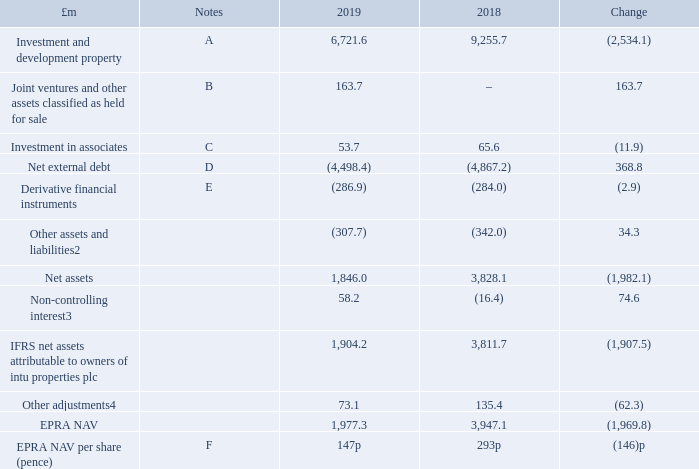IFRS balance sheet items
Our total investment in joint ventures was £524.1 million at 31 December 2019 (which includes investments in joint ventures of £326.6 million and loans to joint ventures £197.5 million), a decrease of £299.8 million from 31 December 2018. The key driver in the year related to the share of loss of joint ventures of £158.9 million, which primarily included underlying earnings of £27.9 million and a property revaluation deficit of £182.9 million, a £200.7 million transfer of intu Puerto Venecia and intu Asturias to held for sale, partially offset by the residual interest in intu Derby of £93.9 million being classified as a joint venture.
We are exposed to foreign exchange movements on our overseas investments. At 31 December 2019 the exposure was 24 per cent of net assets attributable to shareholders, the increase from the 31 December 2018 exposure of 15 per cent being due to the property revaluation deficit in the UK. Adjusted for the disposals in intu Puerto Venecia and intu Asturias, this exposure would be reduced to 15 per cent.
1 A reconciliation from the IFRS consolidated balance sheet to the amounts presented above is provided in the presentation of information on page 159. A further reconciliation of EPRA NAV to IFRS net assets attributable to owners of intu properties plc is provided within EPRA measures on page 169.
2 Other assets and liabilities includes property, plant and equipment, other non-current assets, trade and other receivables, trade and other payables, current tax liabilities, deferred tax liabilities and other payables.
3 Relates primarily to our partner’s 40 per cent stake in intu Metrocentre. The amount is considered to be recoverable in view of the £195.4 million owed to the non-controlling interest (which is included in the Group’s borrowings in note 23).
4 Other adjustments relate to fair value of derivative financial instruments, fair value of convertible bonds, deferred tax on investment and development property, share of joint ventures’ adjusted items and non-controlling interest recoverable balance not recognised in EPRA NAV.
The key drivers in the decrease in IFRS net assets attributable to owners of intu properties plc of £1,907.5 million as well as the decrease in EPRA NAV of £1,969.8 million and EPRA NAV per share of 146 pence in the year are discussed below.
A Investment and development property
Investment and development property has decreased by £2,534.1 million:
—deficit on revaluation of £1,979.7 million (see E above within the income statement section)
—disposals in the year, including the part disposal of intu Derby in July 2019, transfer of intu Puerto Venecia and intu Asturias to assets held for sale (see B below) and sundry asset disposals
—capital expenditure of £129.2 million on projects enhancing the value and appeal of our centres, including £44.5 million on the Primark anchored intu Trafford Centre’s Barton Square extension, £14.5 million on the redevelopment of intu Broadmarsh and £11.2 million on the now completed leisure extension at intu Lakeside
B Joint ventures and other assets classified as held for sale
intu Puerto Venecia and intu Asturias were classified as joint ventures held for sale at 31 December 2019 and recognised at their expected net proceeds.
intu Puerto Venecia
In December 2019 the Group announced the disposal of its joint venture interest in intu Puerto Venecia to Generali Shopping Centre Fund S.C.S. SICAV-SIF and Union Investment Real Estate GMBH for €475.3 million (intu share €237.7 million), an 11 per cent discount to the June 2019 valuation. This is expected to complete in early April and deliver net proceeds to intu of around £95.4 million after repaying asset-level debt, working capital adjustments, fees and taxation.
What is the net assets in 2019?
Answer scale should be: million. 1,846.0. What is the EPRA NAV in 2018?
Answer scale should be: million. 3,947.1. What is the change in EPRA NAV per share (pence) from 2018 to 2019? (146). What is the percentage change in the total investment in joint ventures from 2018 to 2019?
Answer scale should be: percent. -299.8/(524.1+299.8)
Answer: -36.39. What is the percentage change in the EPRA NAV from 2018 to 2019?
Answer scale should be: percent. -(1,969.8/3,947.1)
Answer: -49.9. What is the percentage change in the IFRS net assets attributable to owners of intu properties plc from 2018 to 2019?
Answer scale should be: percent. -1,907.5/3,811.7
Answer: -50.04. 